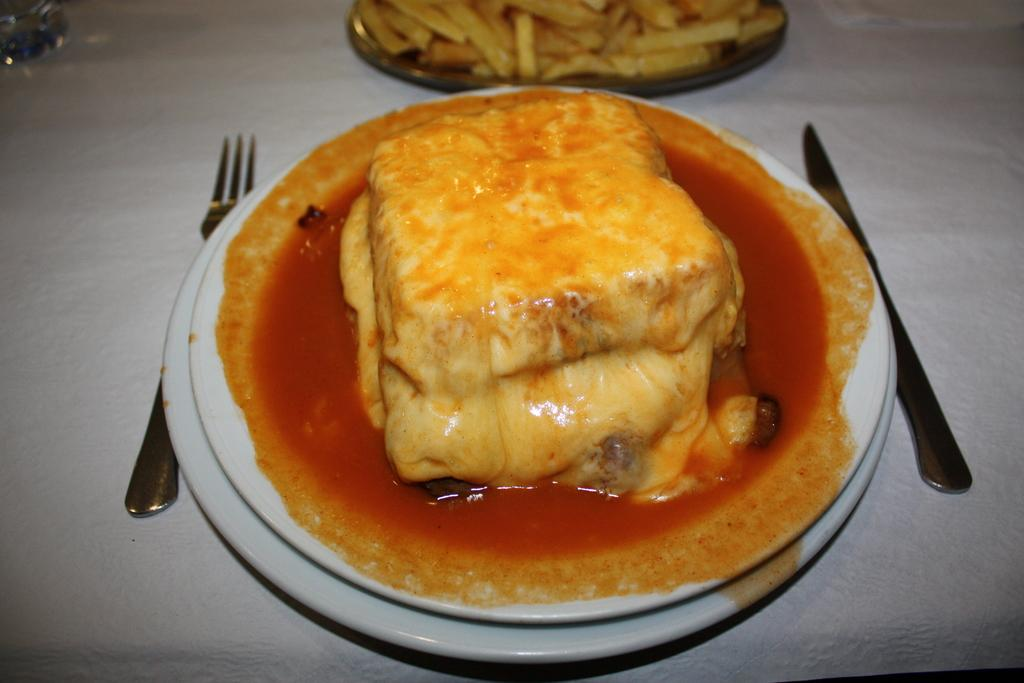What is on the plate that is visible in the image? There is food placed on a plate in the image. Can you describe the other plate of food in the image? There is another plate of food placed on the backdrop. What utensils are present in the image? There is a fork and a knife in the image. What type of zephyr can be seen blowing the cabbage leaves in the image? There is no zephyr or cabbage present in the image. How many roses are placed on the plate with the food in the image? There are no roses present on the plate with the food in the image. 